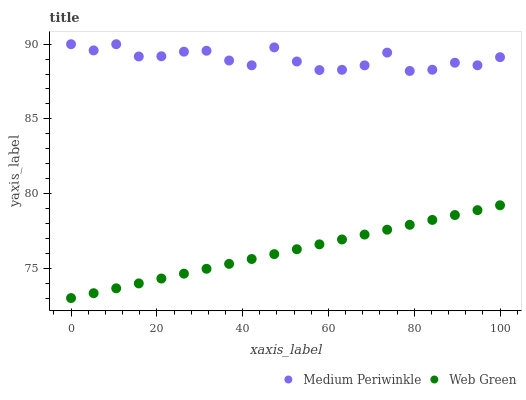Does Web Green have the minimum area under the curve?
Answer yes or no. Yes. Does Medium Periwinkle have the maximum area under the curve?
Answer yes or no. Yes. Does Web Green have the maximum area under the curve?
Answer yes or no. No. Is Web Green the smoothest?
Answer yes or no. Yes. Is Medium Periwinkle the roughest?
Answer yes or no. Yes. Is Web Green the roughest?
Answer yes or no. No. Does Web Green have the lowest value?
Answer yes or no. Yes. Does Medium Periwinkle have the highest value?
Answer yes or no. Yes. Does Web Green have the highest value?
Answer yes or no. No. Is Web Green less than Medium Periwinkle?
Answer yes or no. Yes. Is Medium Periwinkle greater than Web Green?
Answer yes or no. Yes. Does Web Green intersect Medium Periwinkle?
Answer yes or no. No. 